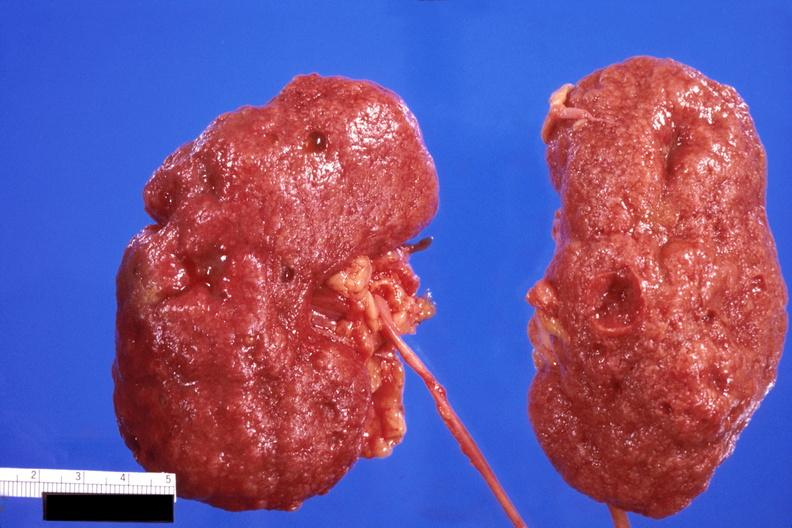where is this?
Answer the question using a single word or phrase. Urinary 